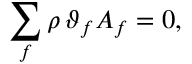<formula> <loc_0><loc_0><loc_500><loc_500>\sum _ { f } \rho \, \vartheta _ { f } A _ { f } = 0 ,</formula> 